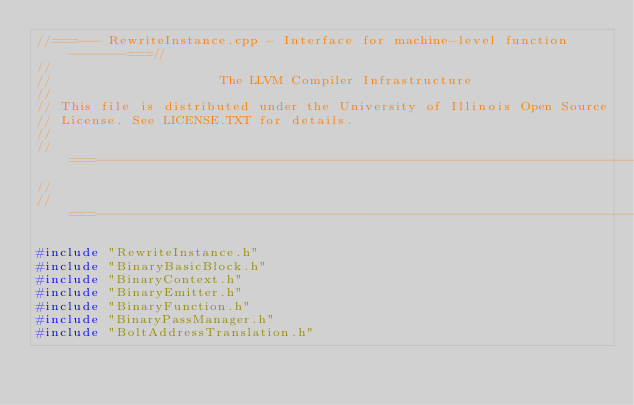<code> <loc_0><loc_0><loc_500><loc_500><_C++_>//===--- RewriteInstance.cpp - Interface for machine-level function -------===//
//
//                     The LLVM Compiler Infrastructure
//
// This file is distributed under the University of Illinois Open Source
// License. See LICENSE.TXT for details.
//
//===----------------------------------------------------------------------===//
//
//===----------------------------------------------------------------------===//

#include "RewriteInstance.h"
#include "BinaryBasicBlock.h"
#include "BinaryContext.h"
#include "BinaryEmitter.h"
#include "BinaryFunction.h"
#include "BinaryPassManager.h"
#include "BoltAddressTranslation.h"</code> 